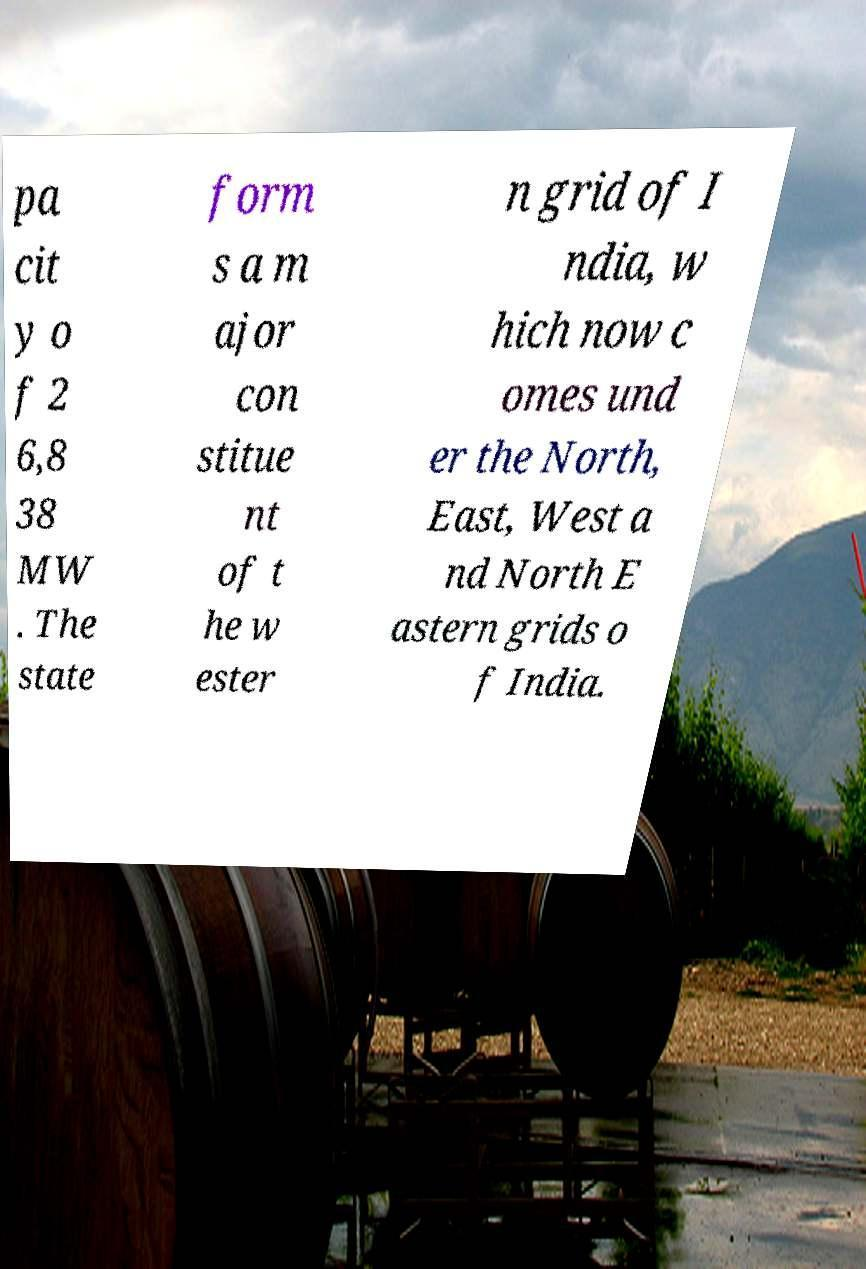Please read and relay the text visible in this image. What does it say? pa cit y o f 2 6,8 38 MW . The state form s a m ajor con stitue nt of t he w ester n grid of I ndia, w hich now c omes und er the North, East, West a nd North E astern grids o f India. 